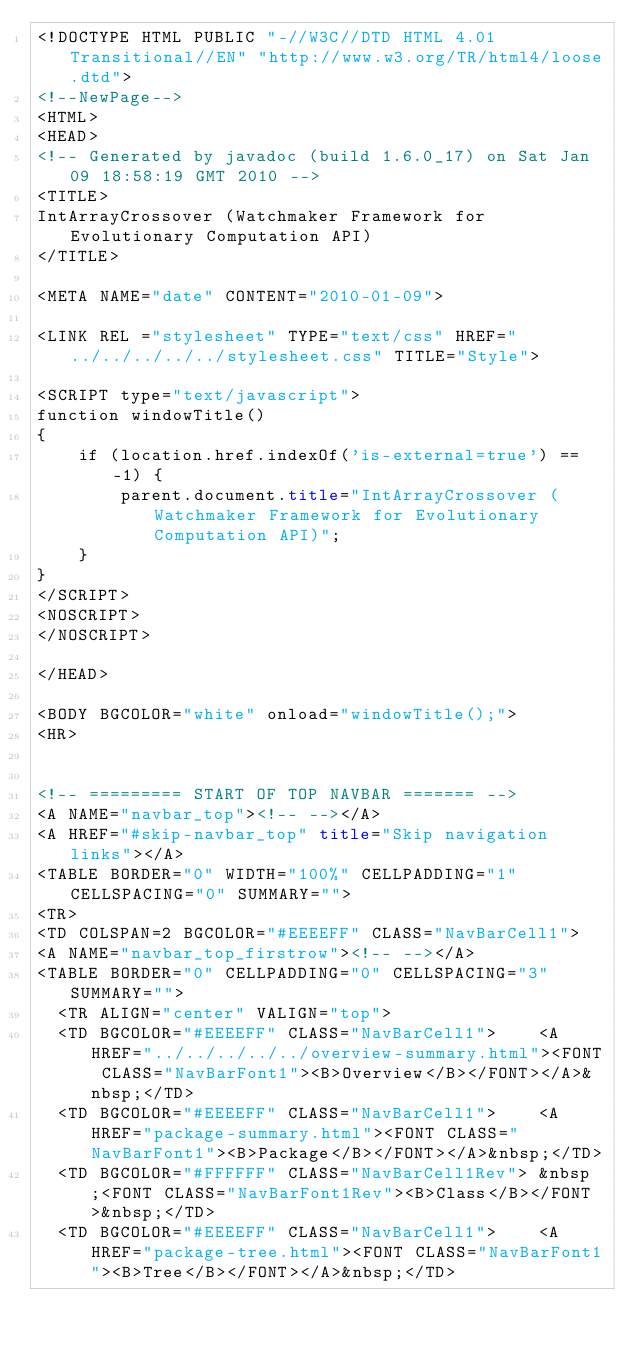Convert code to text. <code><loc_0><loc_0><loc_500><loc_500><_HTML_><!DOCTYPE HTML PUBLIC "-//W3C//DTD HTML 4.01 Transitional//EN" "http://www.w3.org/TR/html4/loose.dtd">
<!--NewPage-->
<HTML>
<HEAD>
<!-- Generated by javadoc (build 1.6.0_17) on Sat Jan 09 18:58:19 GMT 2010 -->
<TITLE>
IntArrayCrossover (Watchmaker Framework for Evolutionary Computation API)
</TITLE>

<META NAME="date" CONTENT="2010-01-09">

<LINK REL ="stylesheet" TYPE="text/css" HREF="../../../../../stylesheet.css" TITLE="Style">

<SCRIPT type="text/javascript">
function windowTitle()
{
    if (location.href.indexOf('is-external=true') == -1) {
        parent.document.title="IntArrayCrossover (Watchmaker Framework for Evolutionary Computation API)";
    }
}
</SCRIPT>
<NOSCRIPT>
</NOSCRIPT>

</HEAD>

<BODY BGCOLOR="white" onload="windowTitle();">
<HR>


<!-- ========= START OF TOP NAVBAR ======= -->
<A NAME="navbar_top"><!-- --></A>
<A HREF="#skip-navbar_top" title="Skip navigation links"></A>
<TABLE BORDER="0" WIDTH="100%" CELLPADDING="1" CELLSPACING="0" SUMMARY="">
<TR>
<TD COLSPAN=2 BGCOLOR="#EEEEFF" CLASS="NavBarCell1">
<A NAME="navbar_top_firstrow"><!-- --></A>
<TABLE BORDER="0" CELLPADDING="0" CELLSPACING="3" SUMMARY="">
  <TR ALIGN="center" VALIGN="top">
  <TD BGCOLOR="#EEEEFF" CLASS="NavBarCell1">    <A HREF="../../../../../overview-summary.html"><FONT CLASS="NavBarFont1"><B>Overview</B></FONT></A>&nbsp;</TD>
  <TD BGCOLOR="#EEEEFF" CLASS="NavBarCell1">    <A HREF="package-summary.html"><FONT CLASS="NavBarFont1"><B>Package</B></FONT></A>&nbsp;</TD>
  <TD BGCOLOR="#FFFFFF" CLASS="NavBarCell1Rev"> &nbsp;<FONT CLASS="NavBarFont1Rev"><B>Class</B></FONT>&nbsp;</TD>
  <TD BGCOLOR="#EEEEFF" CLASS="NavBarCell1">    <A HREF="package-tree.html"><FONT CLASS="NavBarFont1"><B>Tree</B></FONT></A>&nbsp;</TD></code> 